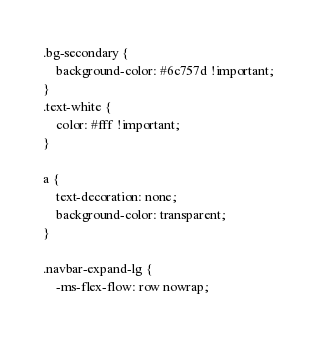<code> <loc_0><loc_0><loc_500><loc_500><_CSS_>.bg-secondary {
    background-color: #6c757d !important;
}
.text-white {
    color: #fff !important;
}

a {
    text-decoration: none;
    background-color: transparent;
}

.navbar-expand-lg {
    -ms-flex-flow: row nowrap;</code> 